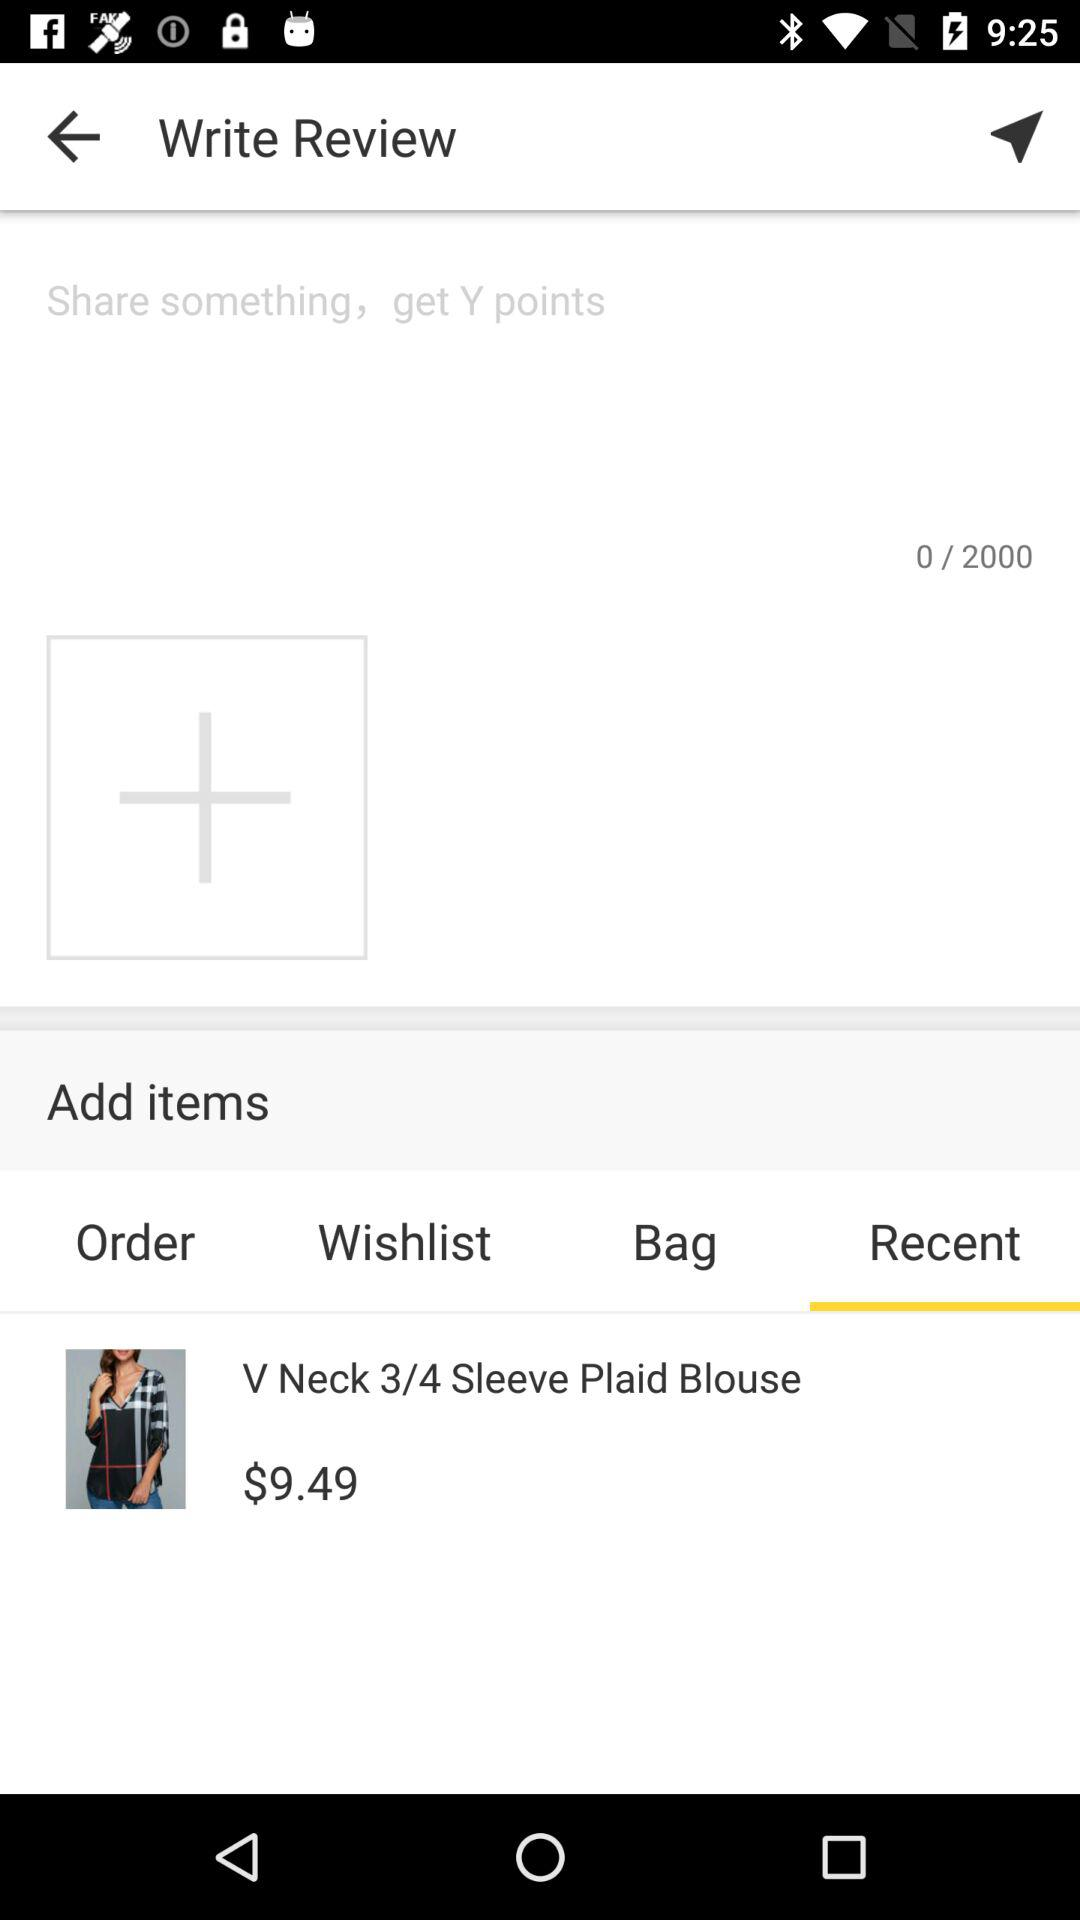How many bags are there?
When the provided information is insufficient, respond with <no answer>. <no answer> 